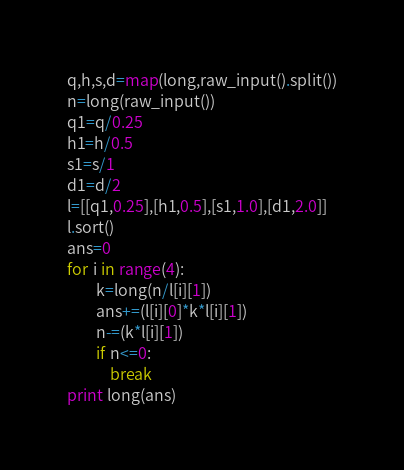Convert code to text. <code><loc_0><loc_0><loc_500><loc_500><_Python_>q,h,s,d=map(long,raw_input().split())
n=long(raw_input())
q1=q/0.25
h1=h/0.5
s1=s/1
d1=d/2
l=[[q1,0.25],[h1,0.5],[s1,1.0],[d1,2.0]]
l.sort()
ans=0
for i in range(4):
        k=long(n/l[i][1])
        ans+=(l[i][0]*k*l[i][1])
        n-=(k*l[i][1])
        if n<=0:
            break
print long(ans)
</code> 